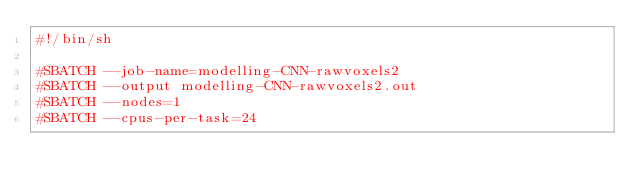Convert code to text. <code><loc_0><loc_0><loc_500><loc_500><_Bash_>#!/bin/sh

#SBATCH --job-name=modelling-CNN-rawvoxels2
#SBATCH --output modelling-CNN-rawvoxels2.out
#SBATCH --nodes=1
#SBATCH --cpus-per-task=24</code> 